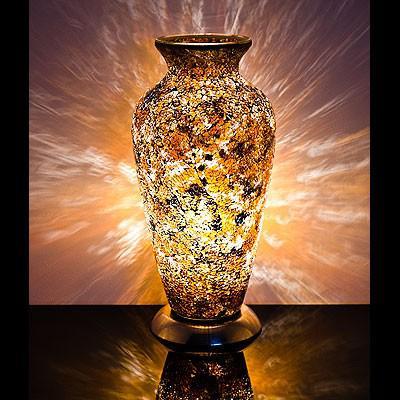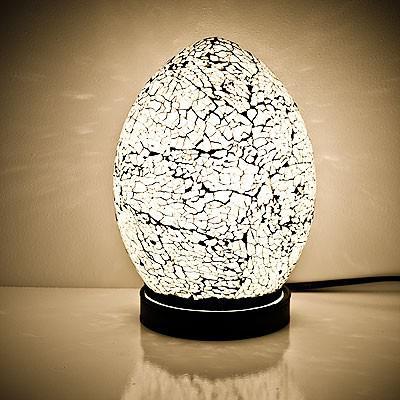The first image is the image on the left, the second image is the image on the right. Assess this claim about the two images: "The right image shows a glowing egg shape on a black base, while the left image shows a vase with a flat, open top.". Correct or not? Answer yes or no. Yes. The first image is the image on the left, the second image is the image on the right. Considering the images on both sides, is "there is a lamp shaped like an egg with the light reflecting on the wall and shiny surface it is sitting on, the base of the lamp is black and has a white line towards the top" valid? Answer yes or no. Yes. 